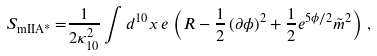<formula> <loc_0><loc_0><loc_500><loc_500>S _ { \text {mIIA*} } = & \frac { 1 } { 2 \kappa _ { 1 0 } ^ { 2 } } \int d ^ { 1 0 } x \, e \, \left ( R - \frac { 1 } { 2 } \left ( \partial { \phi } \right ) ^ { 2 } + \frac { 1 } { 2 } e ^ { 5 \phi / 2 } \tilde { m } ^ { 2 } \right ) \, ,</formula> 